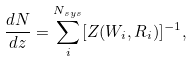<formula> <loc_0><loc_0><loc_500><loc_500>\frac { d N } { d z } = \sum _ { i } ^ { N _ { s y s } } [ Z ( W _ { i } , R _ { i } ) ] ^ { - 1 } ,</formula> 